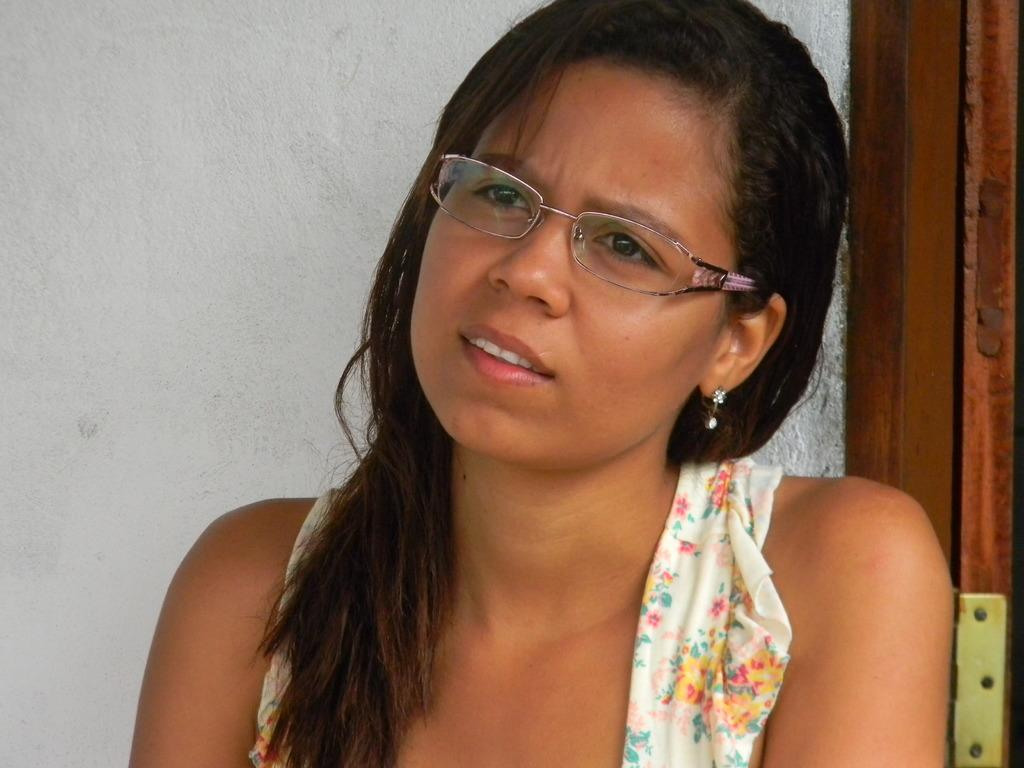Who is the main subject in the foreground of the image? There is a woman in the foreground of the image. What accessory is the woman wearing in the image? The woman is wearing spectacles. What can be seen in the background of the image? There is a wall in the background of the image. What architectural feature is present on the right side of the image? There is a door on the right side of the image. What type of pleasure can be seen being experienced by the woman's mother in the image? There is no indication of the woman's mother being present in the image, nor is there any indication of pleasure being experienced. 